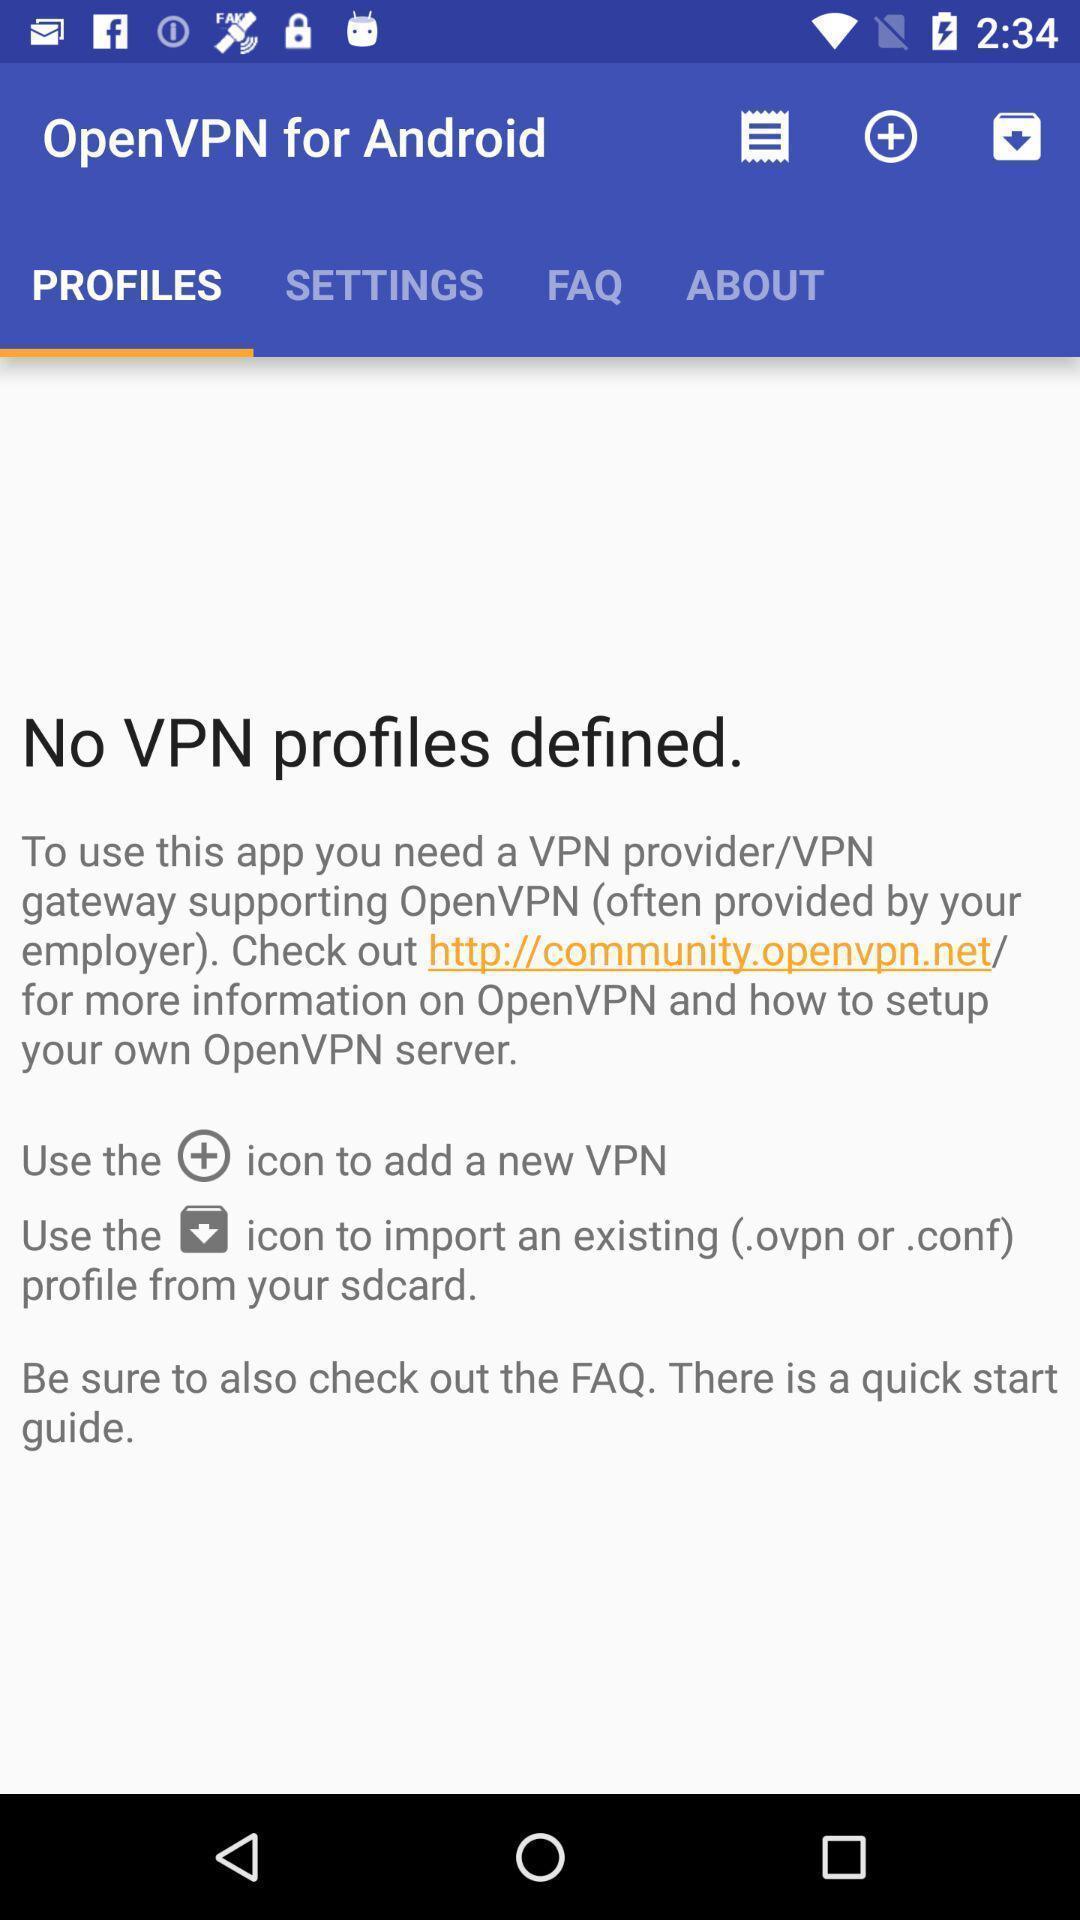Describe this image in words. Screen displaying the profiles page. 